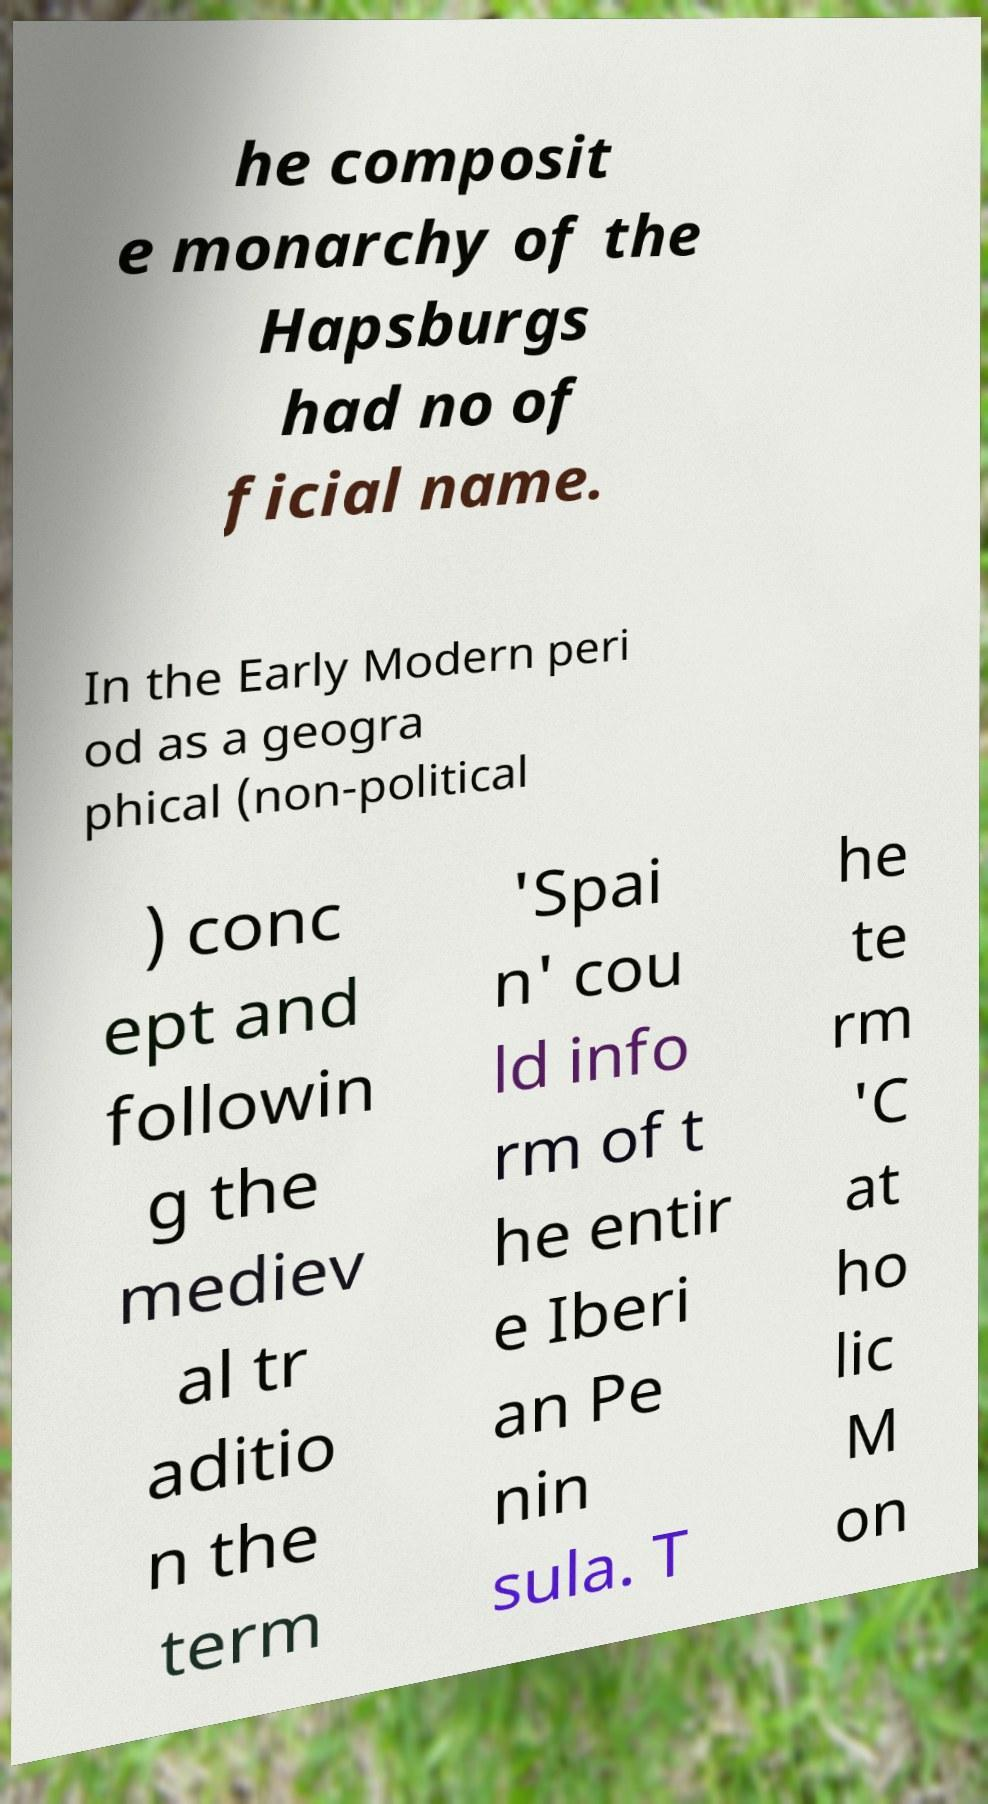Please read and relay the text visible in this image. What does it say? he composit e monarchy of the Hapsburgs had no of ficial name. In the Early Modern peri od as a geogra phical (non-political ) conc ept and followin g the mediev al tr aditio n the term 'Spai n' cou ld info rm of t he entir e Iberi an Pe nin sula. T he te rm 'C at ho lic M on 